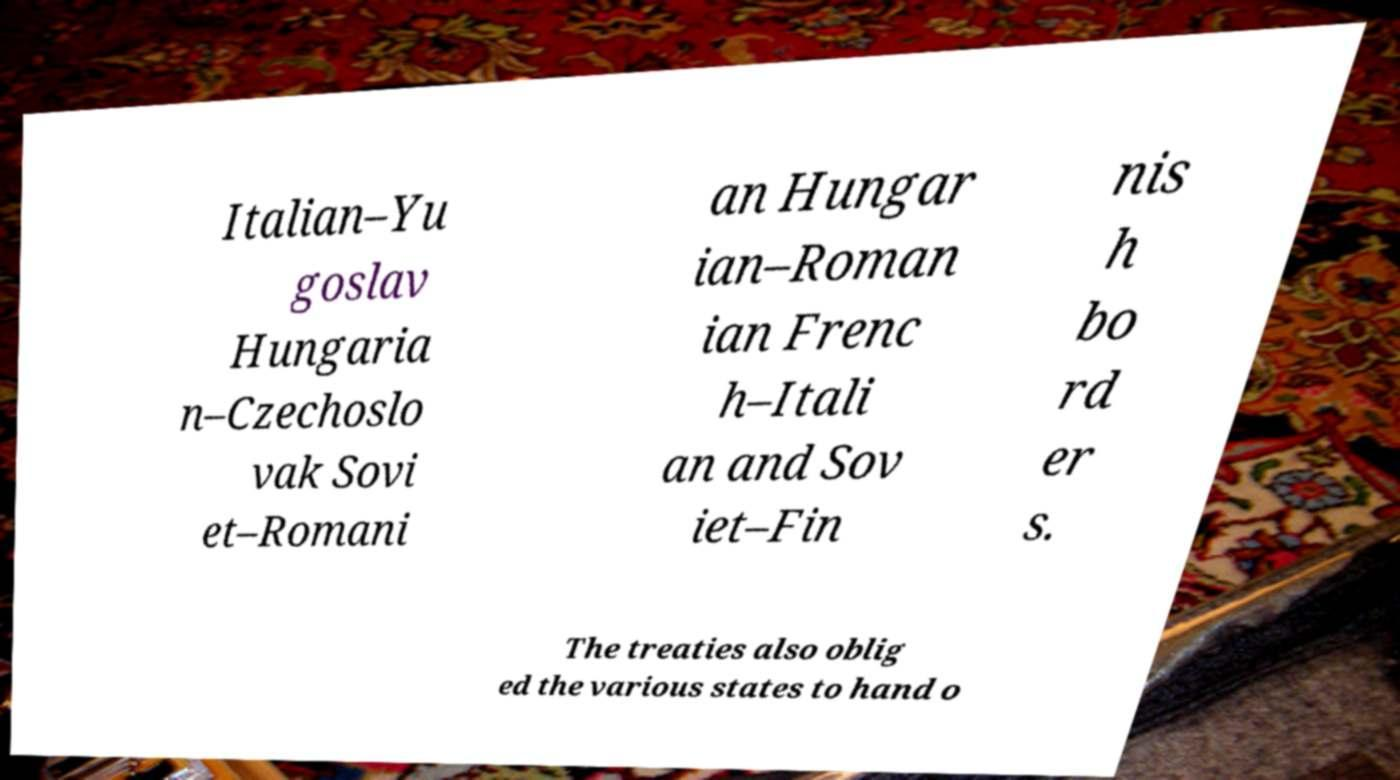What messages or text are displayed in this image? I need them in a readable, typed format. Italian–Yu goslav Hungaria n–Czechoslo vak Sovi et–Romani an Hungar ian–Roman ian Frenc h–Itali an and Sov iet–Fin nis h bo rd er s. The treaties also oblig ed the various states to hand o 